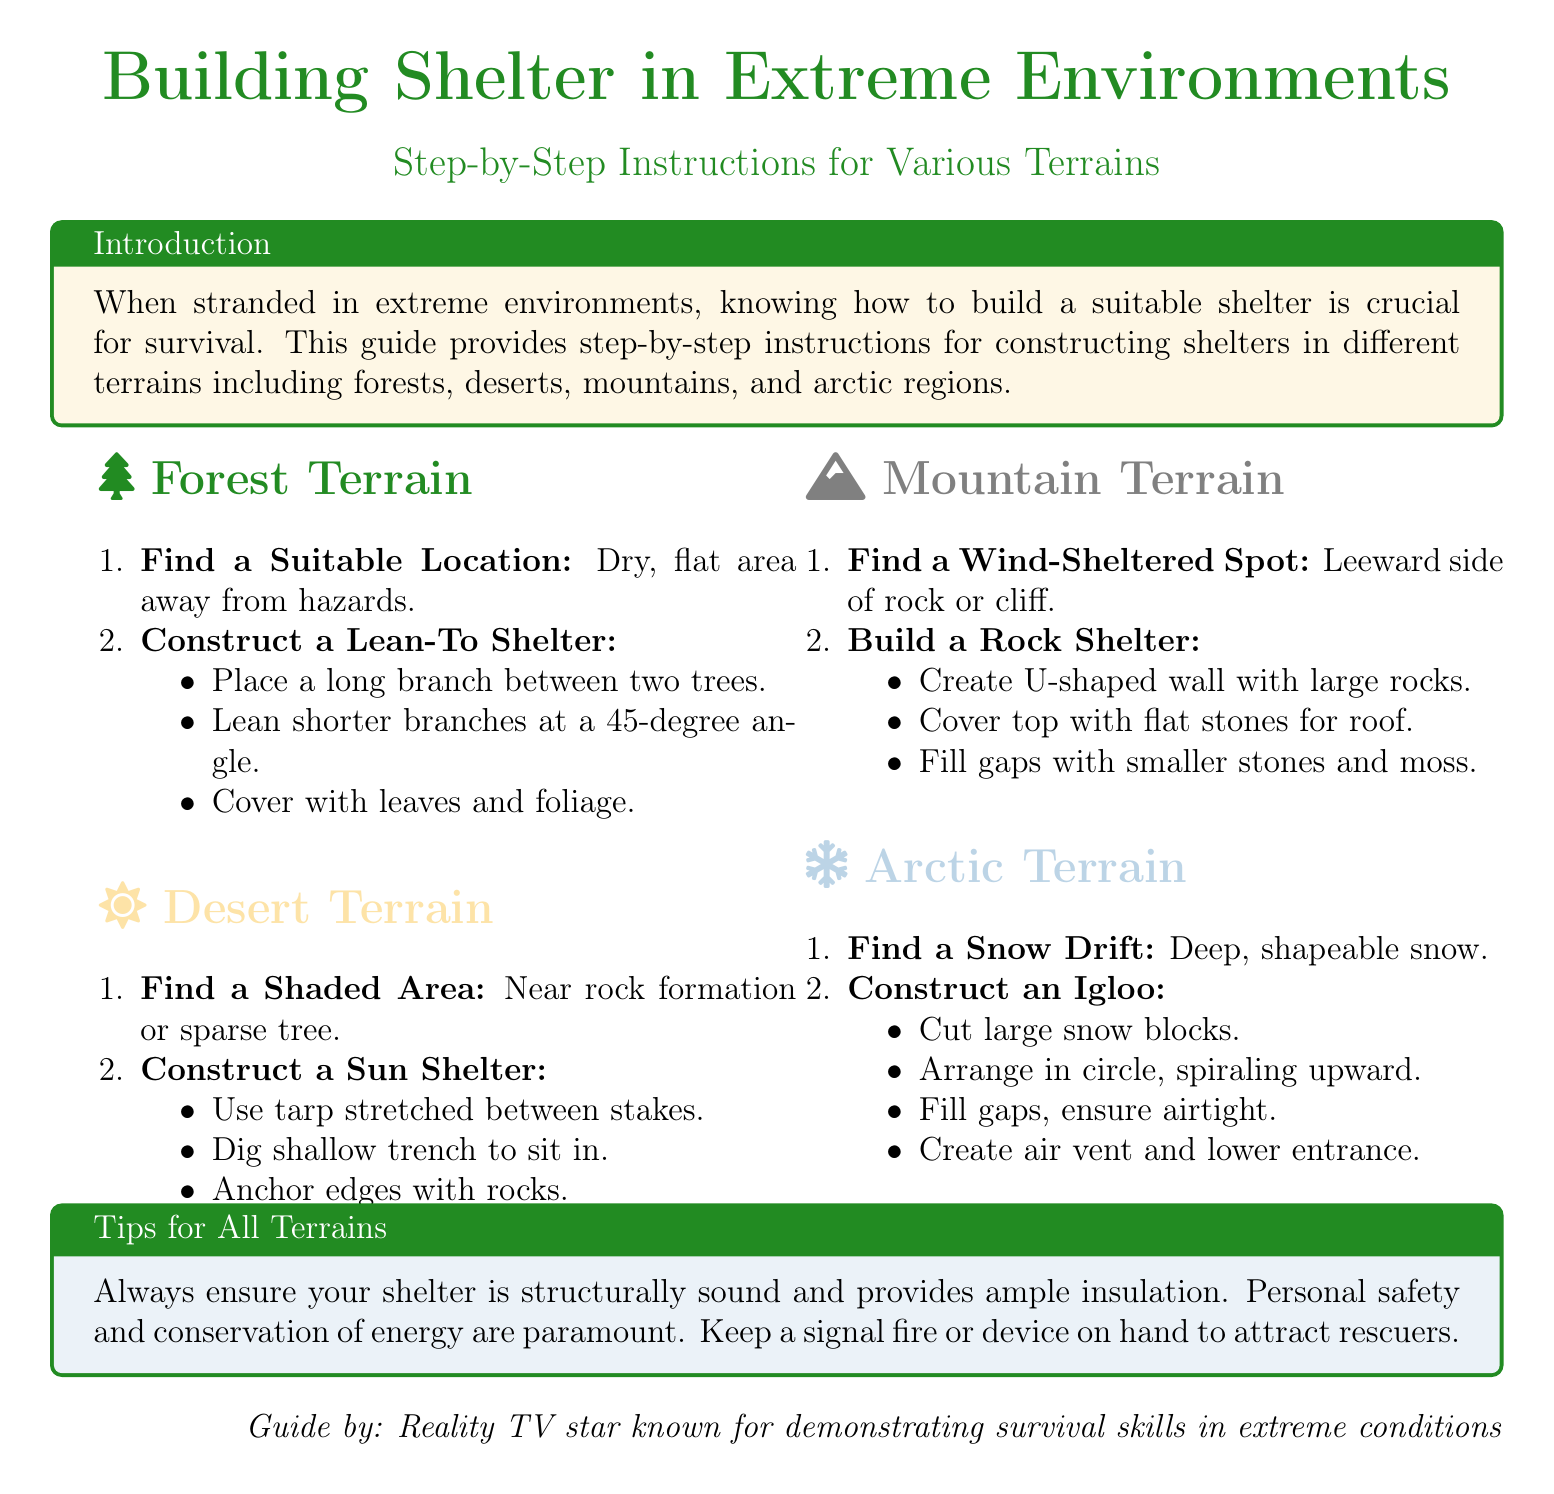what is the title of the guide? The title of the guide is presented in a large font at the beginning of the document.
Answer: Building Shelter in Extreme Environments what terrain requires building an igloo? The document specifies this in the section dedicated to Arctic conditions.
Answer: Arctic Terrain how should you cover a Lean-To shelter? This information is mentioned in the instructions for the forest terrain shelter construction process.
Answer: Cover with leaves and foliage what type of shelter is constructed in desert terrain? The document describes this type of shelter in the relevant section on desert conditions.
Answer: Sun Shelter what is the first step in building a rock shelter? The first step is outlined under the mountain terrain section and is focused on location.
Answer: Find a Wind-Sheltered Spot which material is recommended for filling gaps in a rock shelter? This refers to the specific instructions given in the mountain terrain section.
Answer: Moss what is a crucial aspect to ensure for all shelters? This tip is highlighted in the section outlining safety measures for all terrains.
Answer: Structurally sound what should be created for ventilation in an igloo? This information is provided in the construction steps for the igloo in the arctic terrain section.
Answer: Air vent how does one stabilize a tarp sun shelter? The document explains this step in the desert terrain's construction instructions.
Answer: Anchor edges with rocks 